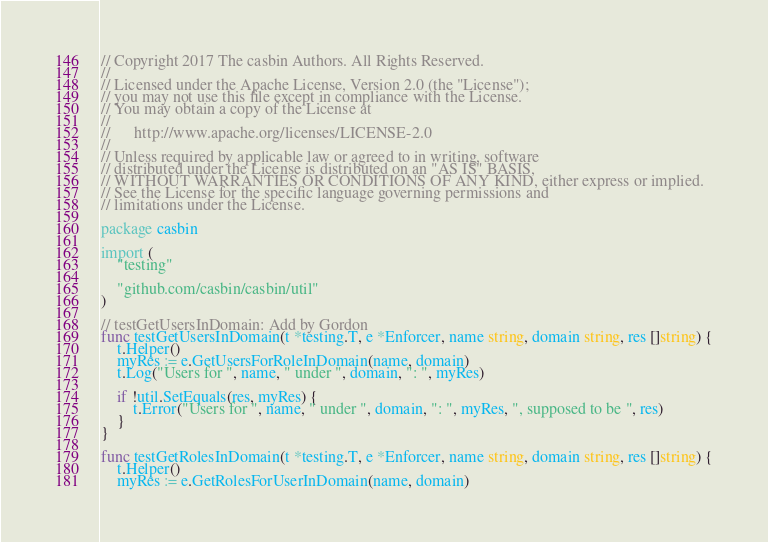<code> <loc_0><loc_0><loc_500><loc_500><_Go_>// Copyright 2017 The casbin Authors. All Rights Reserved.
//
// Licensed under the Apache License, Version 2.0 (the "License");
// you may not use this file except in compliance with the License.
// You may obtain a copy of the License at
//
//      http://www.apache.org/licenses/LICENSE-2.0
//
// Unless required by applicable law or agreed to in writing, software
// distributed under the License is distributed on an "AS IS" BASIS,
// WITHOUT WARRANTIES OR CONDITIONS OF ANY KIND, either express or implied.
// See the License for the specific language governing permissions and
// limitations under the License.

package casbin

import (
	"testing"

	"github.com/casbin/casbin/util"
)

// testGetUsersInDomain: Add by Gordon
func testGetUsersInDomain(t *testing.T, e *Enforcer, name string, domain string, res []string) {
	t.Helper()
	myRes := e.GetUsersForRoleInDomain(name, domain)
	t.Log("Users for ", name, " under ", domain, ": ", myRes)

	if !util.SetEquals(res, myRes) {
		t.Error("Users for ", name, " under ", domain, ": ", myRes, ", supposed to be ", res)
	}
}

func testGetRolesInDomain(t *testing.T, e *Enforcer, name string, domain string, res []string) {
	t.Helper()
	myRes := e.GetRolesForUserInDomain(name, domain)</code> 